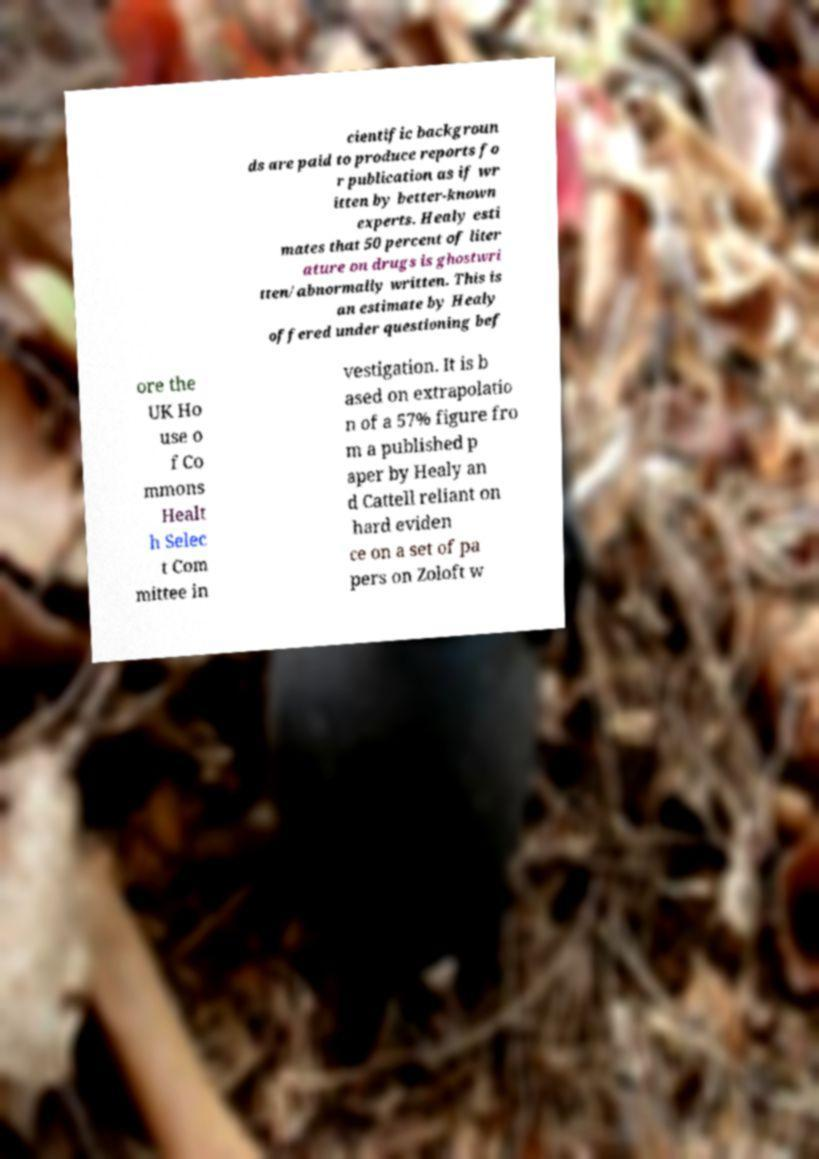Please identify and transcribe the text found in this image. cientific backgroun ds are paid to produce reports fo r publication as if wr itten by better-known experts. Healy esti mates that 50 percent of liter ature on drugs is ghostwri tten/abnormally written. This is an estimate by Healy offered under questioning bef ore the UK Ho use o f Co mmons Healt h Selec t Com mittee in vestigation. It is b ased on extrapolatio n of a 57% figure fro m a published p aper by Healy an d Cattell reliant on hard eviden ce on a set of pa pers on Zoloft w 